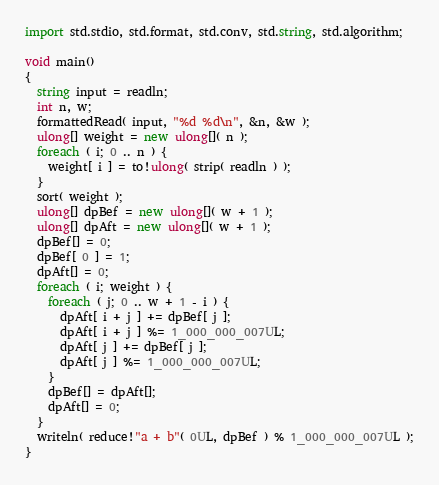<code> <loc_0><loc_0><loc_500><loc_500><_D_>import std.stdio, std.format, std.conv, std.string, std.algorithm;

void main()
{
  string input = readln;
  int n, w;
  formattedRead( input, "%d %d\n", &n, &w );
  ulong[] weight = new ulong[]( n );
  foreach ( i; 0 .. n ) {
	weight[ i ] = to!ulong( strip( readln ) );
  }
  sort( weight );
  ulong[] dpBef = new ulong[]( w + 1 );
  ulong[] dpAft = new ulong[]( w + 1 );
  dpBef[] = 0;
  dpBef[ 0 ] = 1;
  dpAft[] = 0;
  foreach ( i; weight ) {
	foreach ( j; 0 .. w + 1 - i ) {
	  dpAft[ i + j ] += dpBef[ j ];
	  dpAft[ i + j ] %= 1_000_000_007UL;
	  dpAft[ j ] += dpBef[ j ];
	  dpAft[ j ] %= 1_000_000_007UL;
	}
	dpBef[] = dpAft[];
	dpAft[] = 0;
  }
  writeln( reduce!"a + b"( 0UL, dpBef ) % 1_000_000_007UL );
}</code> 